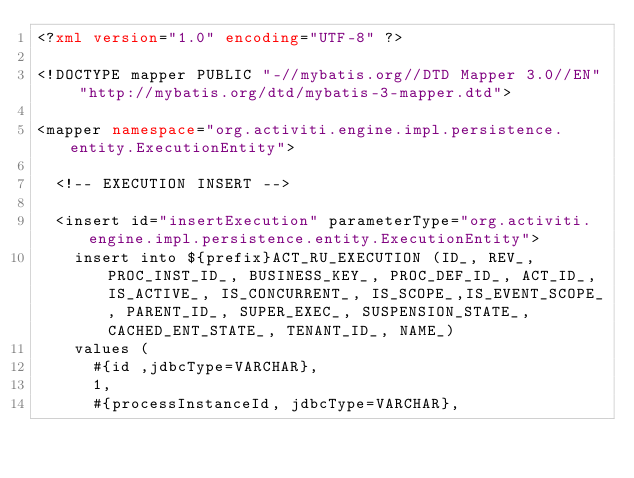<code> <loc_0><loc_0><loc_500><loc_500><_XML_><?xml version="1.0" encoding="UTF-8" ?> 

<!DOCTYPE mapper PUBLIC "-//mybatis.org//DTD Mapper 3.0//EN" "http://mybatis.org/dtd/mybatis-3-mapper.dtd"> 
  
<mapper namespace="org.activiti.engine.impl.persistence.entity.ExecutionEntity">

  <!-- EXECUTION INSERT -->

  <insert id="insertExecution" parameterType="org.activiti.engine.impl.persistence.entity.ExecutionEntity">
    insert into ${prefix}ACT_RU_EXECUTION (ID_, REV_, PROC_INST_ID_, BUSINESS_KEY_, PROC_DEF_ID_, ACT_ID_, IS_ACTIVE_, IS_CONCURRENT_, IS_SCOPE_,IS_EVENT_SCOPE_, PARENT_ID_, SUPER_EXEC_, SUSPENSION_STATE_, CACHED_ENT_STATE_, TENANT_ID_, NAME_)
    values (
      #{id ,jdbcType=VARCHAR},
      1,
      #{processInstanceId, jdbcType=VARCHAR},</code> 